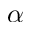<formula> <loc_0><loc_0><loc_500><loc_500>\alpha</formula> 